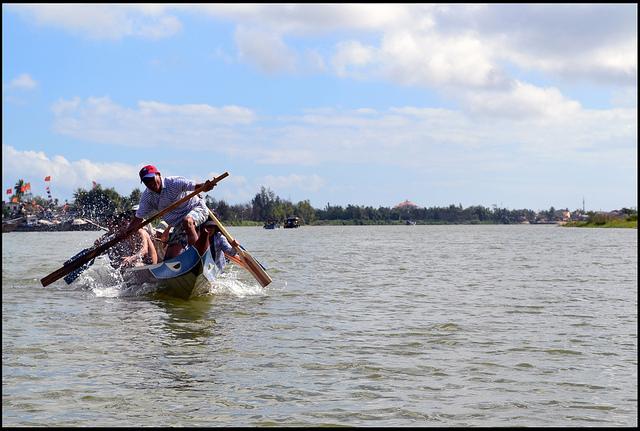What color is the water?
Answer briefly. Brown. How many boats are in the background of this photo?
Quick response, please. 2. Is he wearing a wetsuit?
Keep it brief. No. How are they moving or controlling the boat?
Keep it brief. Paddle. What are the kids riding on?
Quick response, please. Boat. 